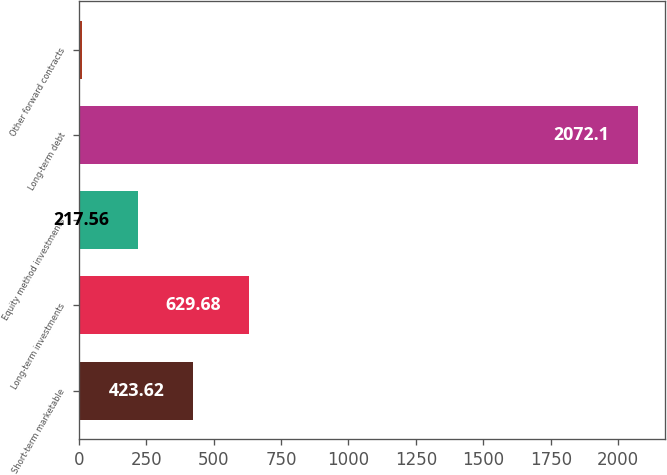Convert chart. <chart><loc_0><loc_0><loc_500><loc_500><bar_chart><fcel>Short-term marketable<fcel>Long-term investments<fcel>Equity method investments<fcel>Long-term debt<fcel>Other forward contracts<nl><fcel>423.62<fcel>629.68<fcel>217.56<fcel>2072.1<fcel>11.5<nl></chart> 